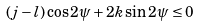Convert formula to latex. <formula><loc_0><loc_0><loc_500><loc_500>( j - l ) \cos 2 \psi + 2 k \sin 2 \psi \leq 0</formula> 